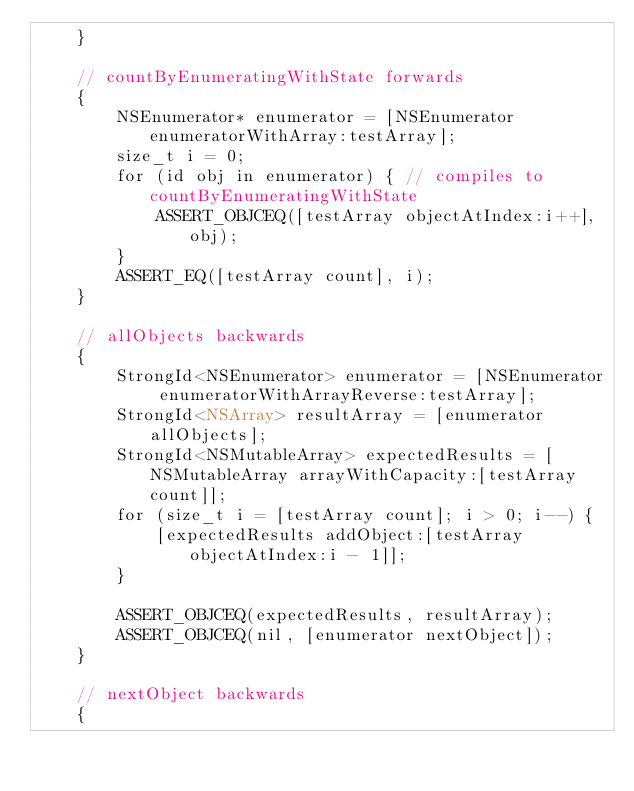Convert code to text. <code><loc_0><loc_0><loc_500><loc_500><_ObjectiveC_>    }

    // countByEnumeratingWithState forwards
    {
        NSEnumerator* enumerator = [NSEnumerator enumeratorWithArray:testArray];
        size_t i = 0;
        for (id obj in enumerator) { // compiles to countByEnumeratingWithState
            ASSERT_OBJCEQ([testArray objectAtIndex:i++], obj);
        }
        ASSERT_EQ([testArray count], i);
    }

    // allObjects backwards
    {
        StrongId<NSEnumerator> enumerator = [NSEnumerator enumeratorWithArrayReverse:testArray];
        StrongId<NSArray> resultArray = [enumerator allObjects];
        StrongId<NSMutableArray> expectedResults = [NSMutableArray arrayWithCapacity:[testArray count]];
        for (size_t i = [testArray count]; i > 0; i--) {
            [expectedResults addObject:[testArray objectAtIndex:i - 1]];
        }

        ASSERT_OBJCEQ(expectedResults, resultArray);
        ASSERT_OBJCEQ(nil, [enumerator nextObject]);
    }

    // nextObject backwards
    {</code> 